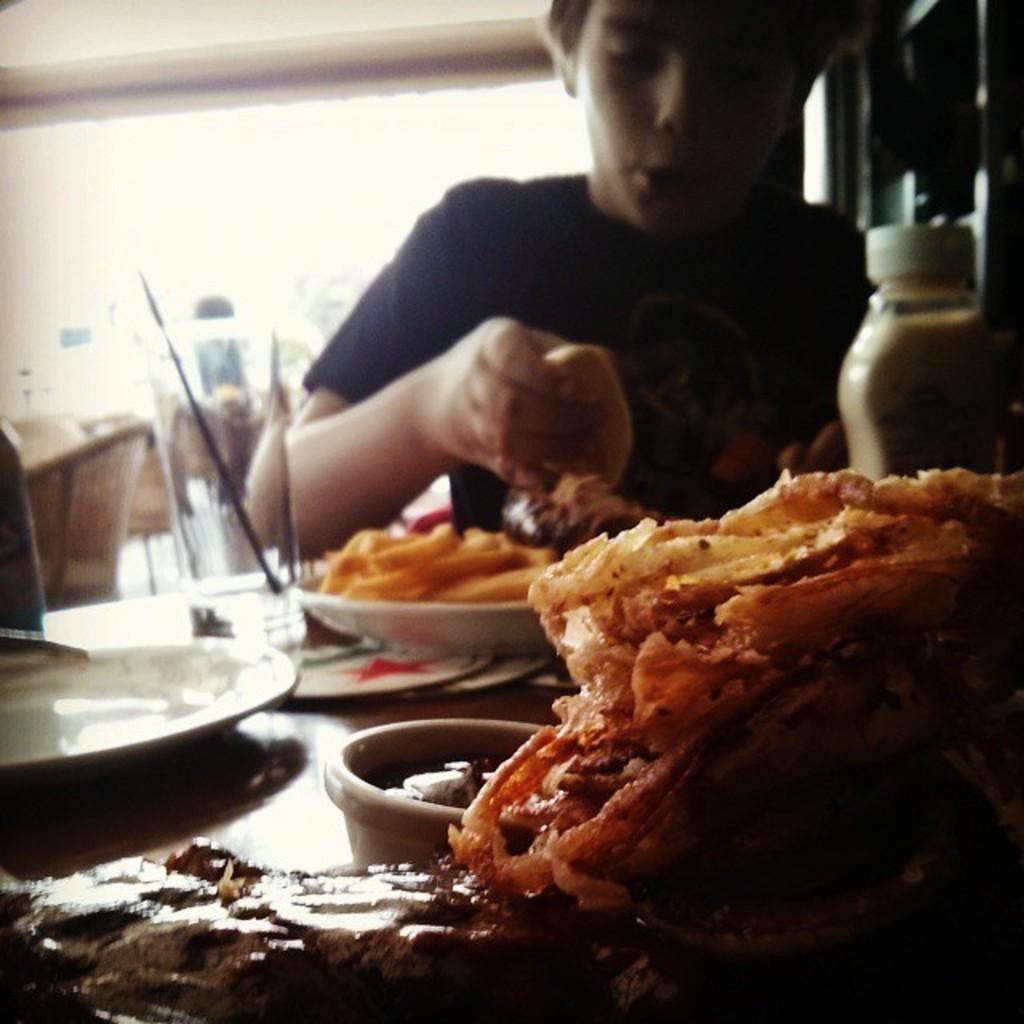Can you describe this image briefly? In this image we can see a boy eating food. In front of the boy we can see a group of food items on a table. Behind the boy we can see the chairs. In the top right, we can see a wooden wall. At the top we can see the roof. 